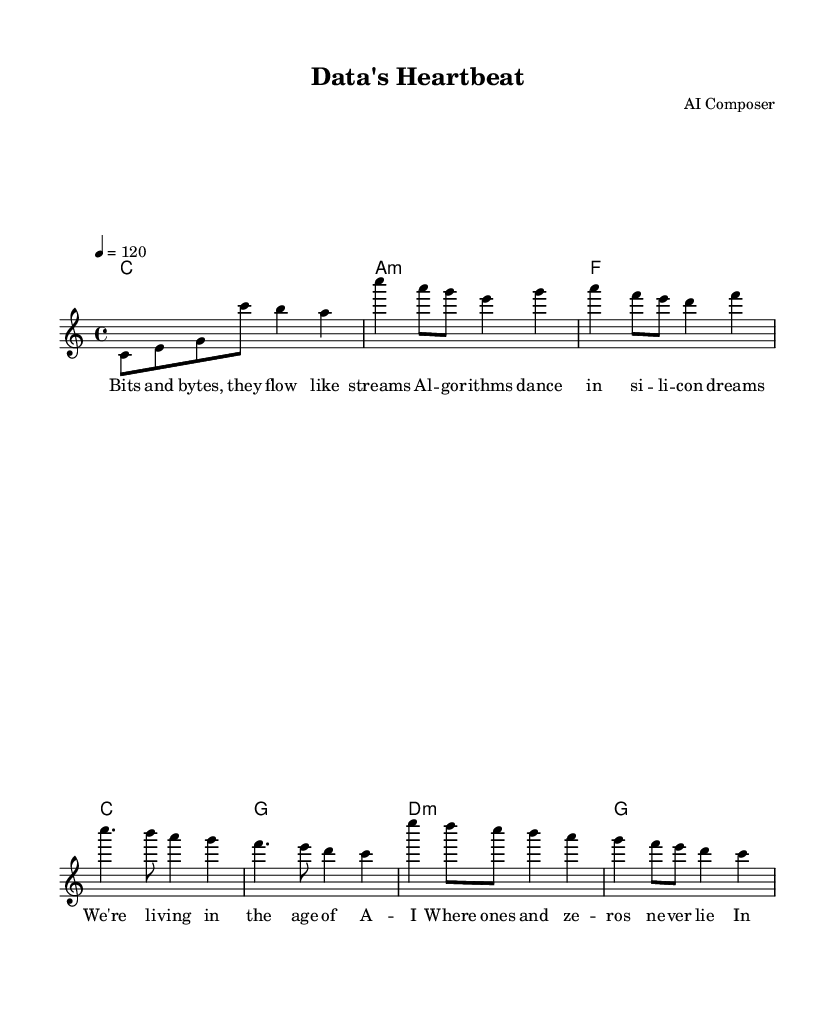What is the key signature of this music? The key signature is C major, which has no sharps or flats.
Answer: C major What is the time signature of the piece? The time signature is indicated at the beginning of the score and shows that there are four beats per measure, which is represented as 4/4.
Answer: 4/4 What is the tempo marking for this composition? The tempo marking is found in the score, specifying how fast the music should be played, indicated as "4 = 120". This means there are 120 beats per minute.
Answer: 120 How many sections are in the song? By analyzing the structure seen in the lyrics and the melody, we have an introduction, a verse, a chorus, and a bridge, which results in four distinct sections.
Answer: 4 What is the first word of the chorus? The first word of the chorus can be found at the beginning of the lyric section that corresponds to the chorus, which is "We're".
Answer: We're How many measures are there in the verse? Counting the measures in the melody corresponding to the verses, we can identify that there are four measures in the verse line.
Answer: 4 Which musical form is used in this piece? By examining the different sections and their repeated nature, we recognize that this piece follows a verse-chorus structure typical of contemporary songs.
Answer: Verse-Chorus 